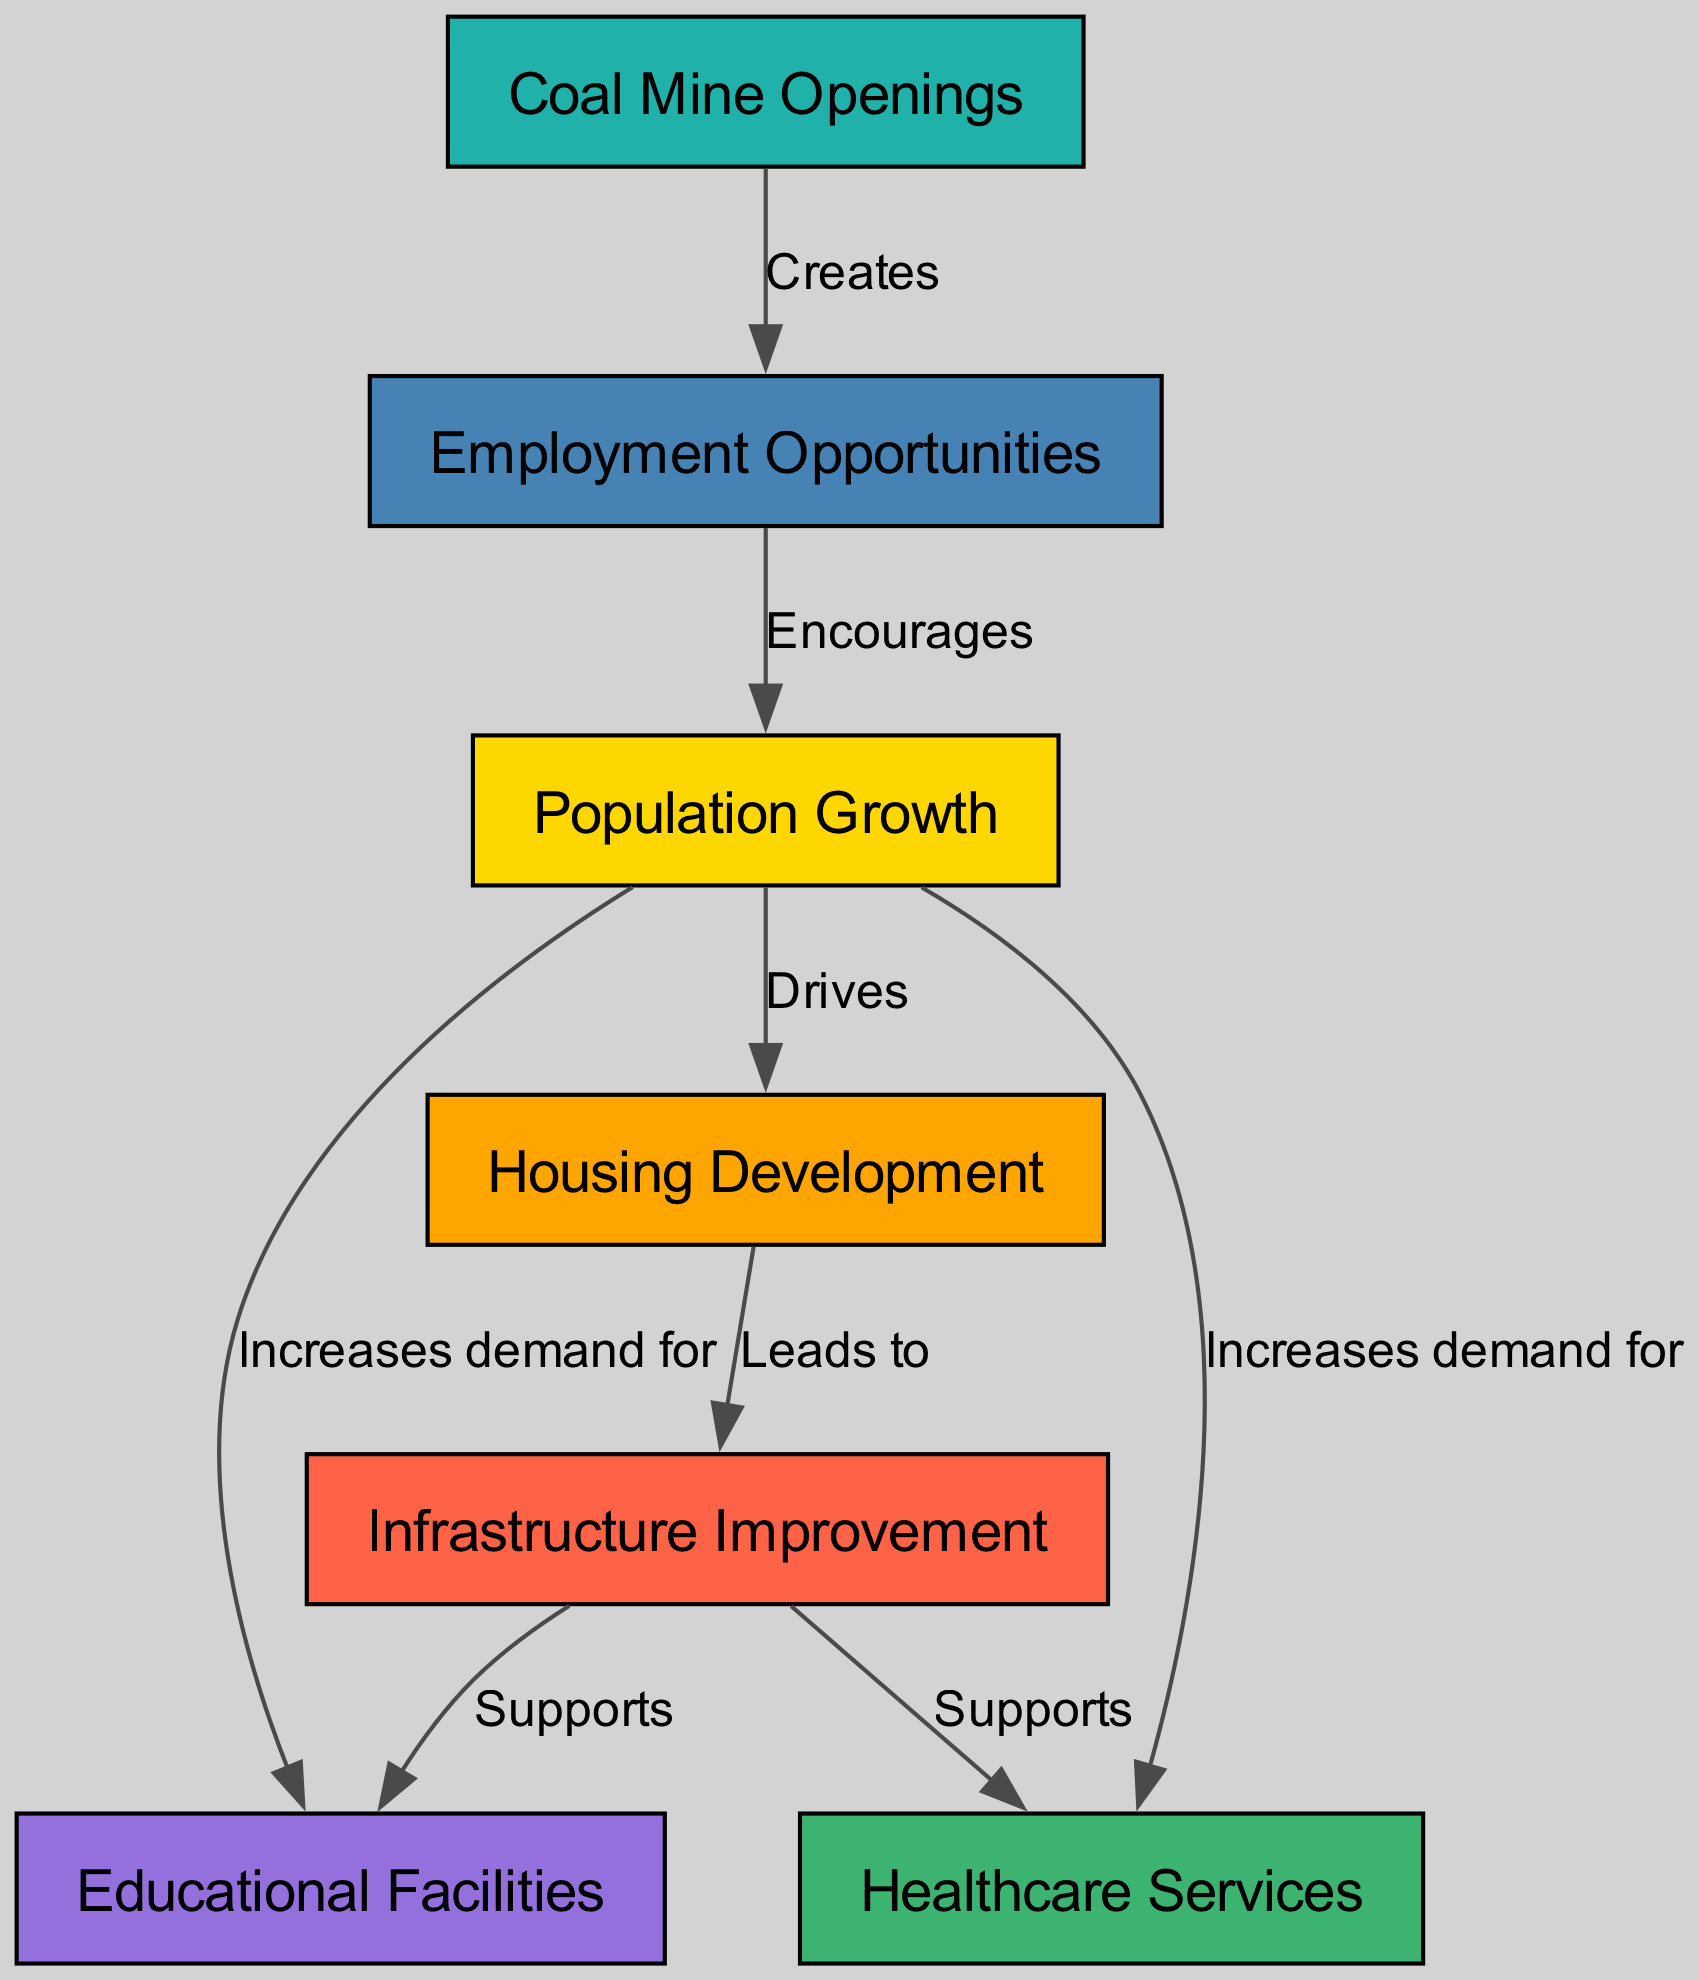What is the starting point in the diagram? The starting point in the diagram is "Coal Mine Openings," as it is the first node connected to the system, leading to employment opportunities.
Answer: Coal Mine Openings How many nodes are in the diagram? By counting the distinct entities in the diagram, there are a total of 7 nodes that represent different aspects of the impact of coal mining on demographics and infrastructure.
Answer: 7 What does employment opportunities encourage? The diagram shows that "Employment Opportunities" encourages "Population Growth," as indicated by the direct connection labeled "Encourages."
Answer: Population Growth What does housing development lead to? The relationship in the diagram indicates that "Housing Development" leads to "Infrastructure Improvement," demonstrating the flow from accommodation needs to better facilities and services.
Answer: Infrastructure Improvement Which two elements are supported by infrastructure improvement? "Educational Facilities" and "Healthcare Services" are both supported by "Infrastructure Improvement," highlighting how better infrastructure contributes to those social services.
Answer: Educational Facilities, Healthcare Services What increases due to population growth regarding facilities? According to the diagram, "Population Growth" increases demand for both "Educational Facilities" and "Healthcare Services," reflecting the needs of a growing population.
Answer: Educational Facilities, Healthcare Services How many edges are connected to the population growth node? By analyzing the connections in the diagram, "Population Growth" has 4 edges leading to "Housing Development," "Employment Opportunities," "Educational Facilities," and "Healthcare Services."
Answer: 4 What relationship shows the connection between housing development and infrastructure improvement? The diagram shows a direct relationship labeled "Leads to," indicating that housing development is a precursor to infrastructure improvement.
Answer: Leads to Which node represents what coal mine openings create? The node that represents what "Coal Mine Openings" create is "Employment Opportunities," as indicated by the edge labeled "Creates."
Answer: Employment Opportunities 